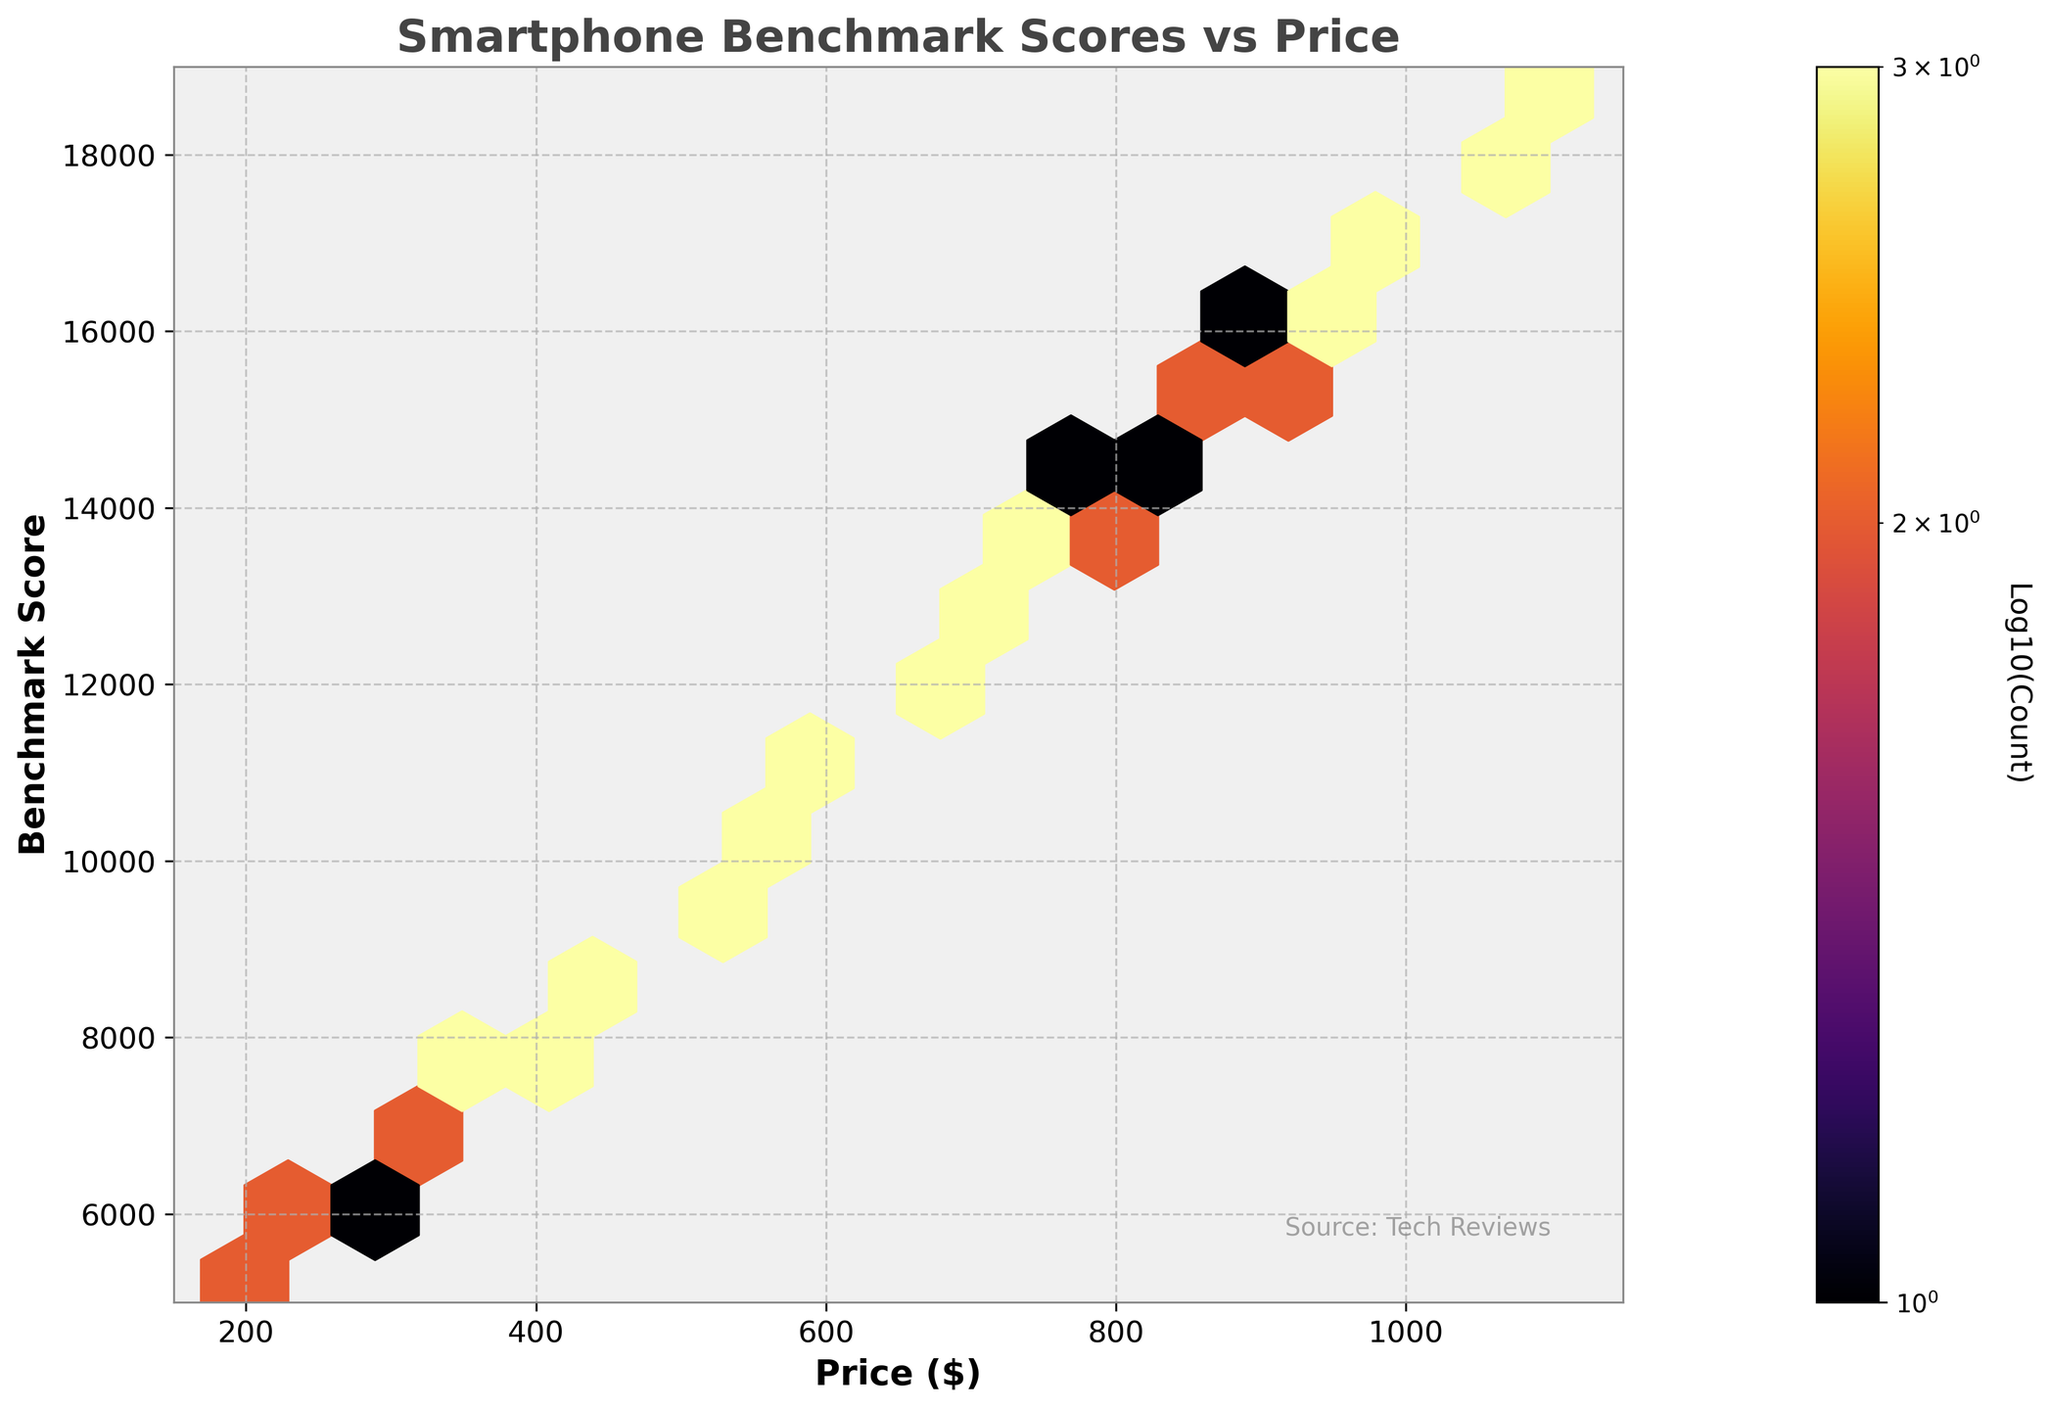What is the title of the plot? The title is a prominent text usually placed at the top of the plot, summarizing the main idea of the figure. By reading the text at the top, we can identify it.
Answer: Smartphone Benchmark Scores vs Price What does the color represent in the plot? The color represents the density of the data points in a specific area. Darker areas indicate higher density (more data points), whereas lighter areas indicate lower density.
Answer: Data point density What is the highest benchmark score shown in the plot? The highest benchmark score is at the top end of the y-axis, this value represents the maximum score recorded in the dataset.
Answer: 18700 Around which price range do we see the highest density of benchmark scores? Look for the darkest hexbin regions on the plot; these regions represent the highest density of data points. The price range where these dark regions are found indicates the area with the most data points.
Answer: $999 to $1099 How does the benchmark score generally change with the increase in price? Observe the trend of the hexbin regions from left to right. As the price increases along the x-axis, the general direction of the denser regions (hexagons) will show how the benchmark scores are trending.
Answer: It generally increases What can be inferred about the benchmark scores for smartphones priced below $500? Notice the benchmark score range for data points corresponding to prices less than $500, which involves analyzing the hexbin regions and their locations on the y-axis for this price range.
Answer: Scores are below 10,000 What's the average benchmark score for smartphones priced between $500 and $600? Identify the hexbin regions within the $500-$600 range on the x-axis, then note their y-axis positions and calculate the average of those benchmark scores.
Answer: Around 11,000 Which price range has the most varied benchmark scores? Look for the price range where the hexbin regions cover the largest vertical span on the y-axis. This indicates a wider distribution of scores within that price range.
Answer: $249 to $299 At a price point of $799, what is the approximate benchmark score? Identify the hexbin region corresponding to the $799 price point on the x-axis and note the corresponding position on the y-axis to find the benchmark score.
Answer: Around 14,000 How does the density of benchmark scores change when comparing the price range $199-$299 with $799-$999? Compare the thickness and darkness of hexbin regions within the $199-$299 price range to those within the $799-$999 range. Analyze if one range has denser (darker) hexbin regions compared to the other.
Answer: $799-$999 has higher density 